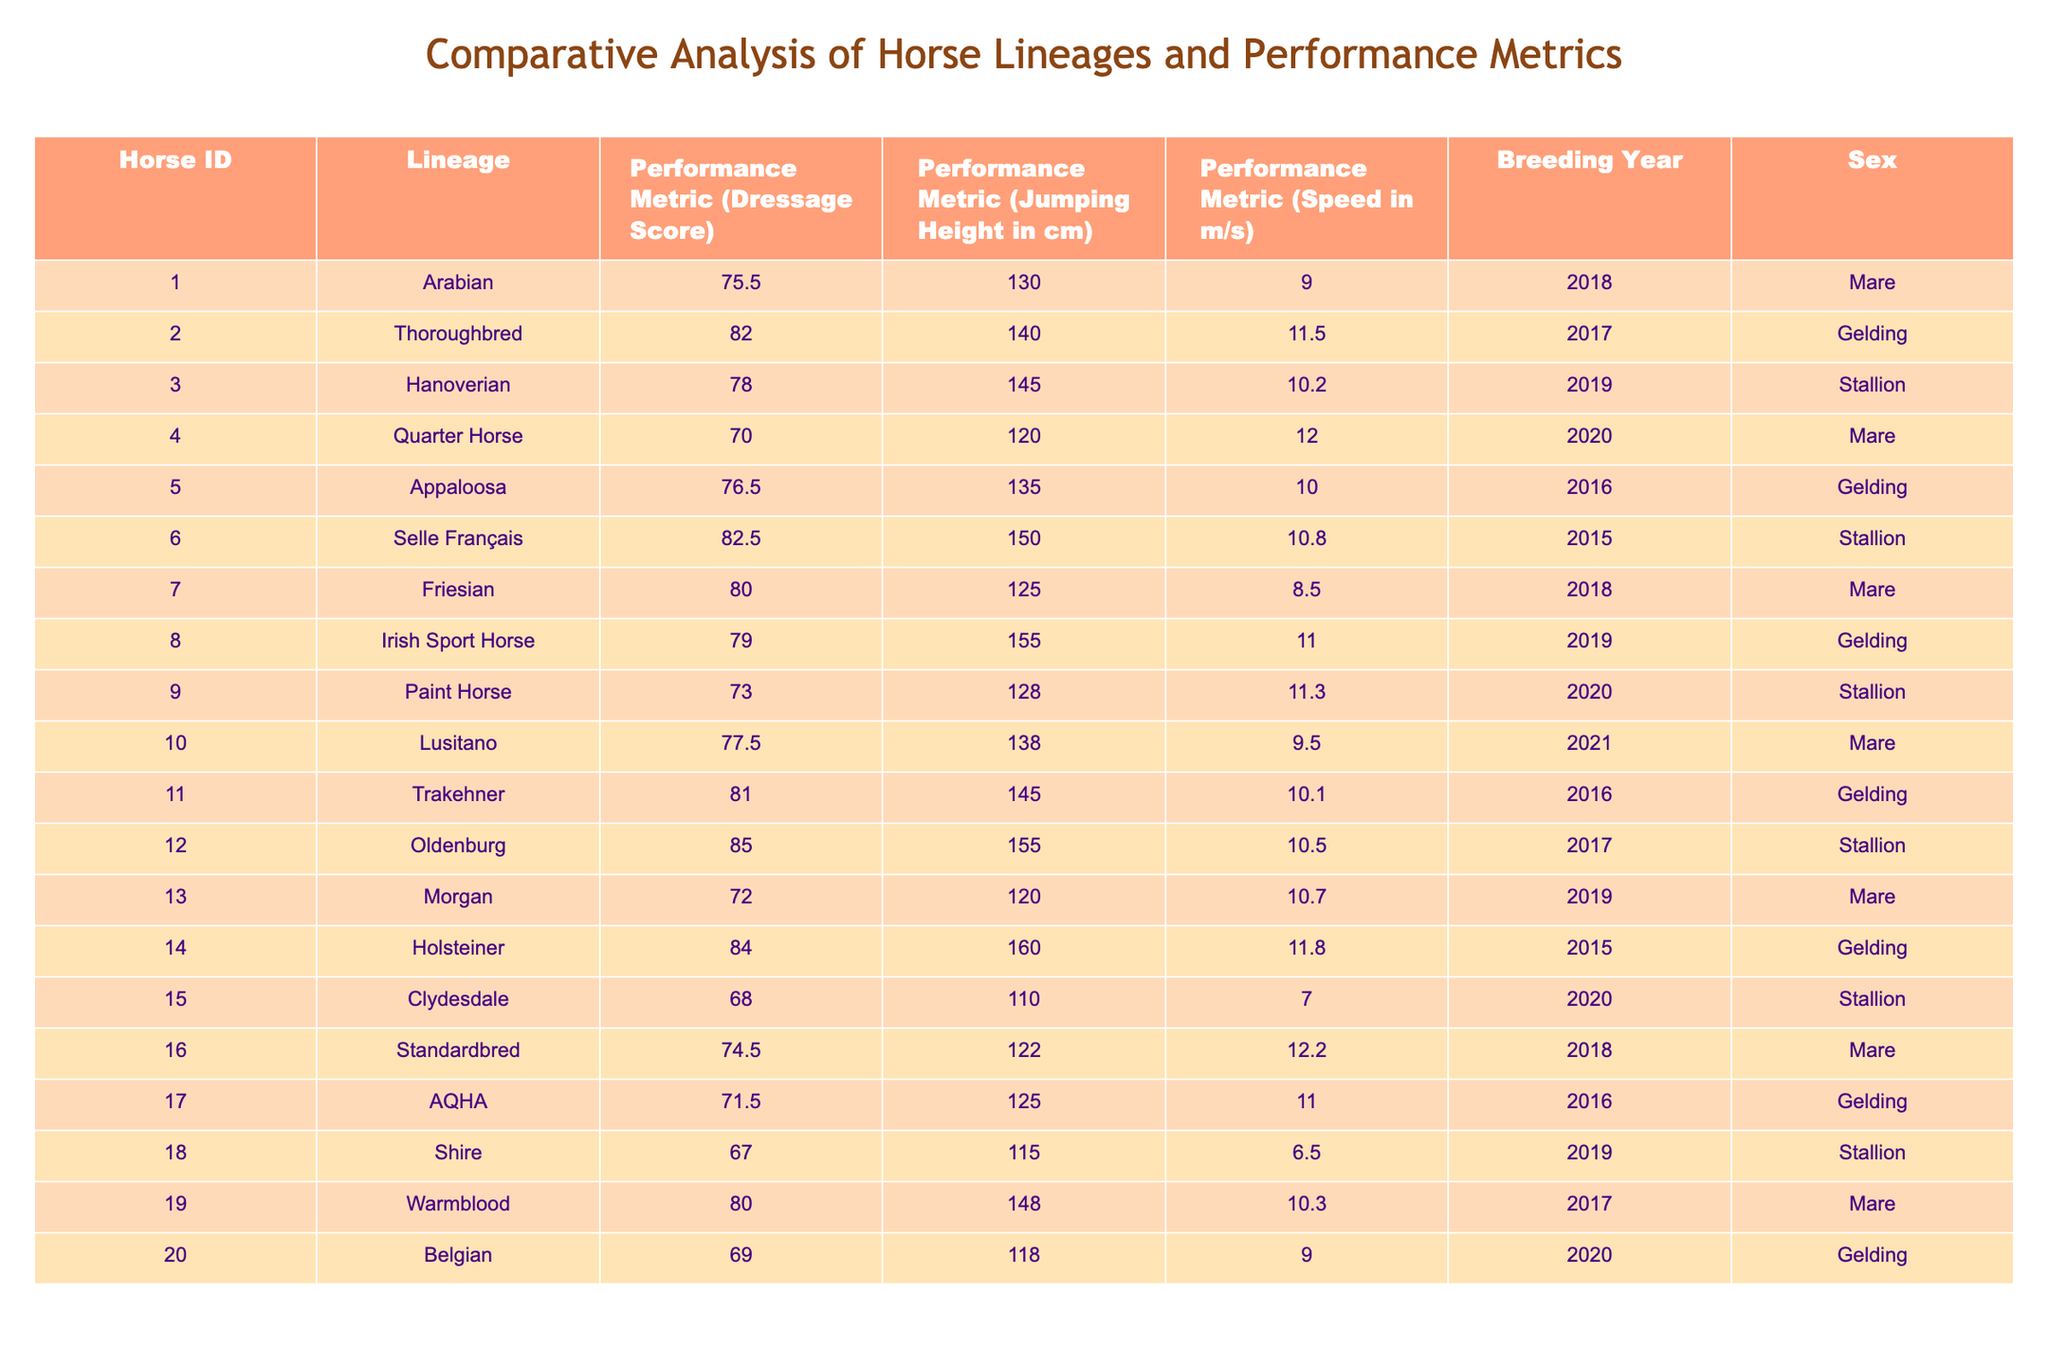What is the highest Dressage Score among the horses? By looking at the Dressage Score column, the highest score listed is 85.0, attributed to the Oldenburg horse (ID 012).
Answer: 85.0 Which horse has the lowest Jumping Height in cm? The Jumping Height column shows that the Clydesdale (ID 015) has the lowest height at 110 cm.
Answer: 110 cm Is the Friesian horse a gelding? The sex of the Friesian (ID 007) is listed as mare, so it is not a gelding.
Answer: No What is the average Speed of all horses? To find the average Speed, sum all the speed values (9.0 + 11.5 + 10.2 + 12.0 + 10.0 + 10.8 + 8.5 + 11.0 + 11.3 + 9.5 + 10.1 + 10.5 + 10.7 + 11.8 + 7.0 + 12.2 + 11.0 + 6.5 + 10.3 + 9.0) which equals 212.0, then divide by 20 (the number of horses), resulting in an average Speed of 10.6 m/s.
Answer: 10.6 m/s How many geldings have a Dressage Score above 75? The geldings are IDs 002, 005, 008, 011, 014, 017, and 020. Among these, the ones with scores above 75 are IDs 002 (82.0), 005 (76.5), 008 (79.0), and 011 (81.0) totaling four horses.
Answer: 4 What is the difference in Jumping Height between the highest and lowest horses? The highest Jumping Height is from the Holsteiner (ID 014) at 160 cm, and the lowest is from the Clydesdale (ID 015) at 110 cm. The difference is 160 - 110 = 50 cm.
Answer: 50 cm Which horse has the best overall performance based on the combination of Dressage Score, Jumping Height, and Speed? The best overall performance could be evaluated by looking at the highest scores in each metric. The horse with the highest Dressage Score is the Oldenburg with 85.0, Jumping Height is the Holsteiner at 160 cm, and Speed is the Thoroughbred at 11.5 m/s. However, considering the average across these metrics for each horse would require calculating weighted performance, thus needing an in-depth analysis.
Answer: Requires calculation How many horses have a Speed greater than 10 m/s and were bred in 2019? The horses bred in 2019 are IDs 003, 008, 013, and 018. The speeds for these horses are 10.2, 11.0, 10.7, and 6.5 respectively. Only two of these, the Hanoverian (10.2) and the Irish Sport Horse (11.0), have speeds greater than 10.
Answer: 2 